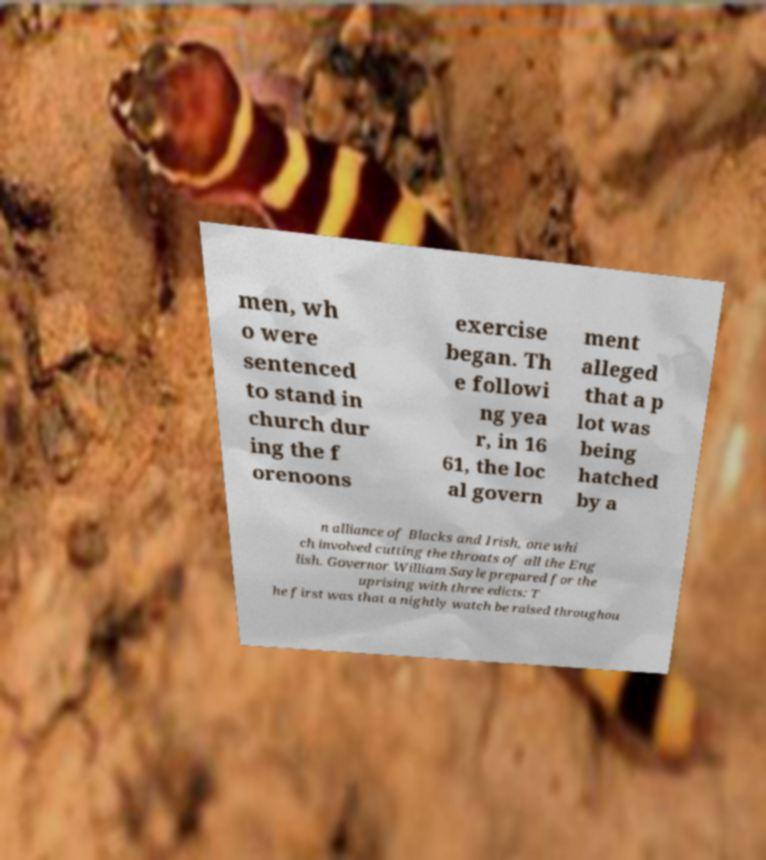Can you read and provide the text displayed in the image?This photo seems to have some interesting text. Can you extract and type it out for me? men, wh o were sentenced to stand in church dur ing the f orenoons exercise began. Th e followi ng yea r, in 16 61, the loc al govern ment alleged that a p lot was being hatched by a n alliance of Blacks and Irish, one whi ch involved cutting the throats of all the Eng lish. Governor William Sayle prepared for the uprising with three edicts: T he first was that a nightly watch be raised throughou 